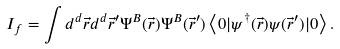Convert formula to latex. <formula><loc_0><loc_0><loc_500><loc_500>I _ { f } = \int d ^ { d } \vec { r } d ^ { d } \vec { r } ^ { \prime } \Psi ^ { B } ( \vec { r } ) \Psi ^ { B } ( \vec { r } ^ { \prime } ) \left < 0 | \psi ^ { \dagger } ( \vec { r } ) \psi ( \vec { r } ^ { \prime } ) | 0 \right > .</formula> 